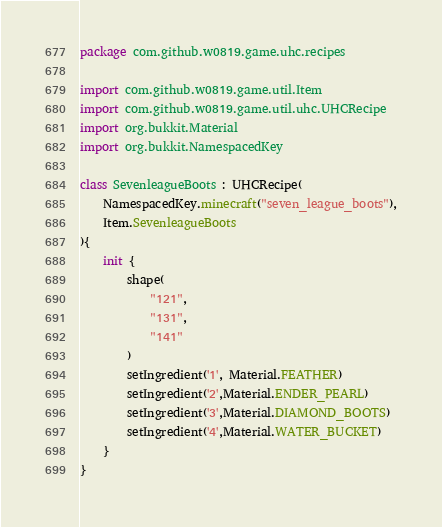Convert code to text. <code><loc_0><loc_0><loc_500><loc_500><_Kotlin_>package com.github.w0819.game.uhc.recipes

import com.github.w0819.game.util.Item
import com.github.w0819.game.util.uhc.UHCRecipe
import org.bukkit.Material
import org.bukkit.NamespacedKey

class SevenleagueBoots : UHCRecipe(
    NamespacedKey.minecraft("seven_league_boots"),
    Item.SevenleagueBoots
){
    init {
        shape(
            "121",
            "131",
            "141"
        )
        setIngredient('1', Material.FEATHER)
        setIngredient('2',Material.ENDER_PEARL)
        setIngredient('3',Material.DIAMOND_BOOTS)
        setIngredient('4',Material.WATER_BUCKET)
    }
}</code> 